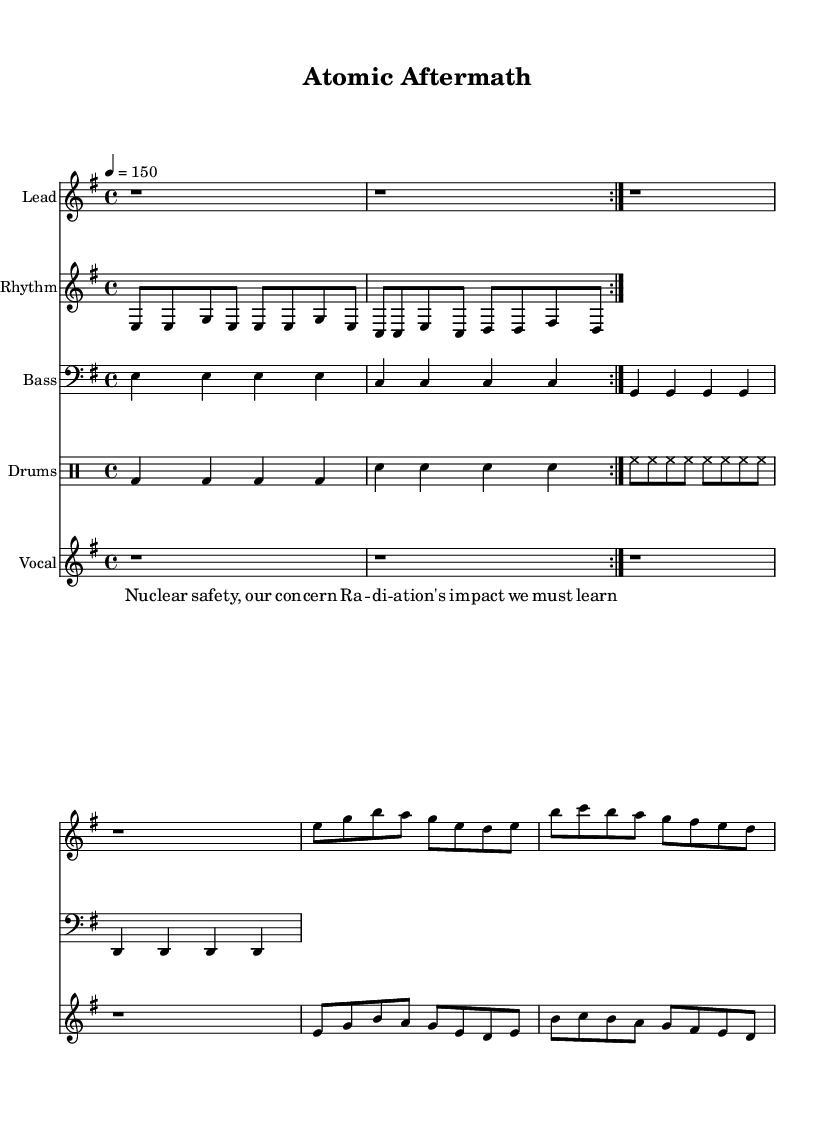What is the key signature of this music? The key signature shows two sharps, which indicates it is in E minor.
Answer: E minor What is the time signature of the piece? The time signature is indicated at the beginning as 4/4, which means there are four beats per measure and the quarter note gets one beat.
Answer: 4/4 What is the tempo marking for this piece? The tempo marking is indicated as 4 equals 150, meaning there are 150 beats per minute.
Answer: 150 How many measures are in the melody section? The melody section has a total of four measures, which can be counted from the notation.
Answer: 4 What instrument is designated for the drums? The sheet music specifies "Drums" as the instrument name for the drum part, which means the notation corresponds to a drum set.
Answer: Drums What thematic concern does the lyrical content address? The lyrics explicitly mention "Radiation's impact," indicating that the song deals with environmental issues related to nuclear safety.
Answer: Nuclear safety How is the musical style of this piece characterized? The aggressive guitar riffs, rapid tempo, and powerful lyrics suggest that this is a heavy metal piece, known for its intensity and thematic depth related to concerns.
Answer: Heavy metal 